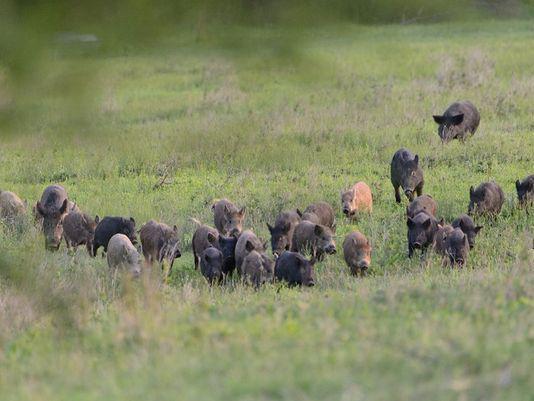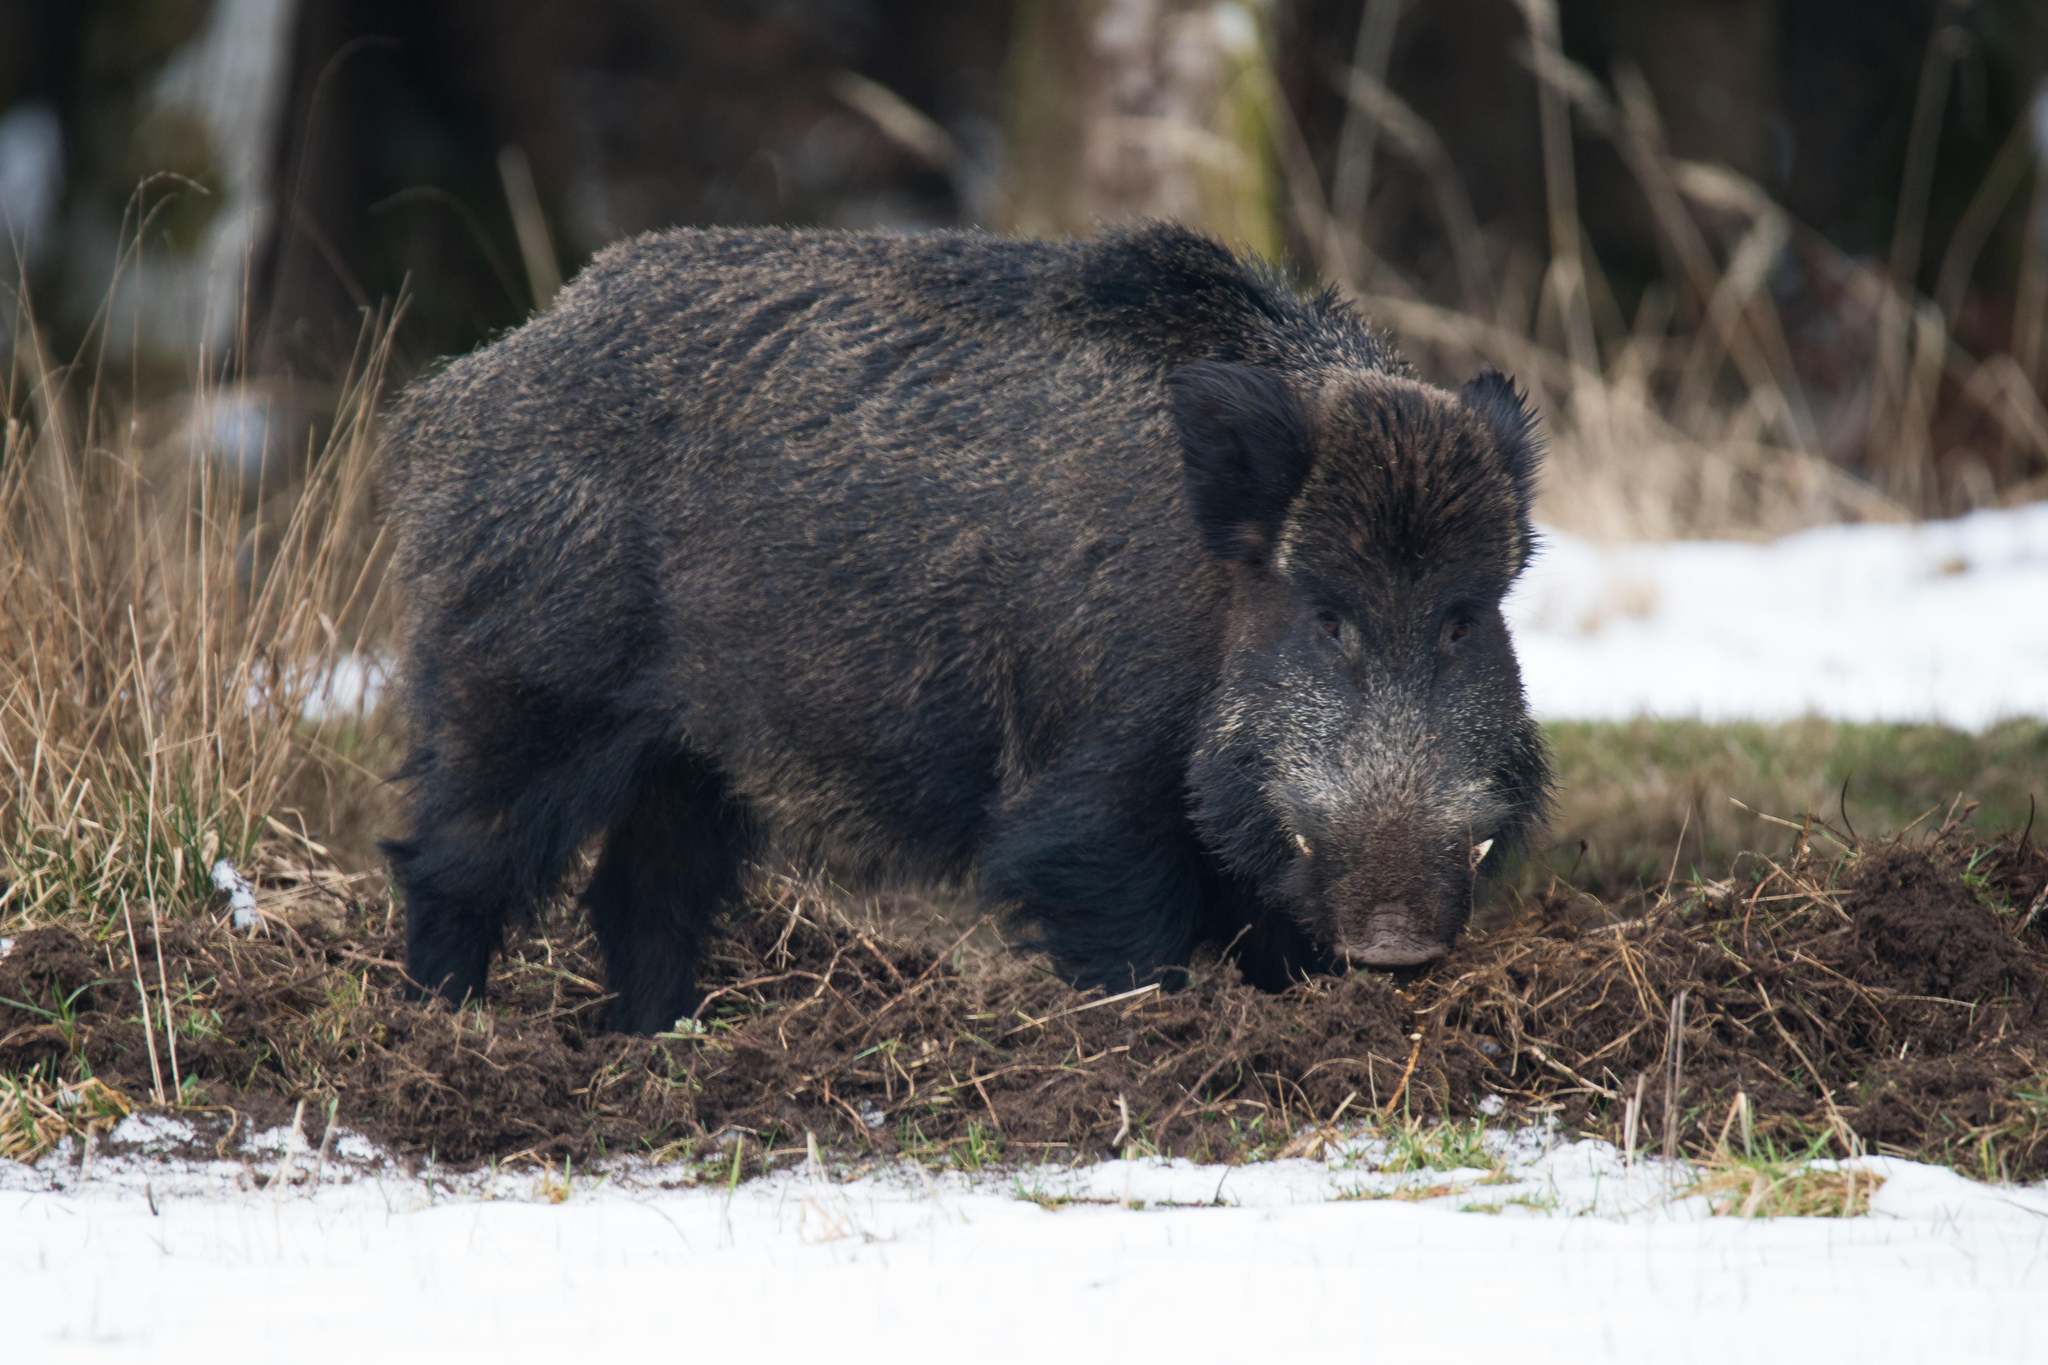The first image is the image on the left, the second image is the image on the right. Given the left and right images, does the statement "There is a man made object in a field in one of the images." hold true? Answer yes or no. No. The first image is the image on the left, the second image is the image on the right. Examine the images to the left and right. Is the description "A group of hogs is garthered near a barrel-shaped feeder on a tripod." accurate? Answer yes or no. No. 